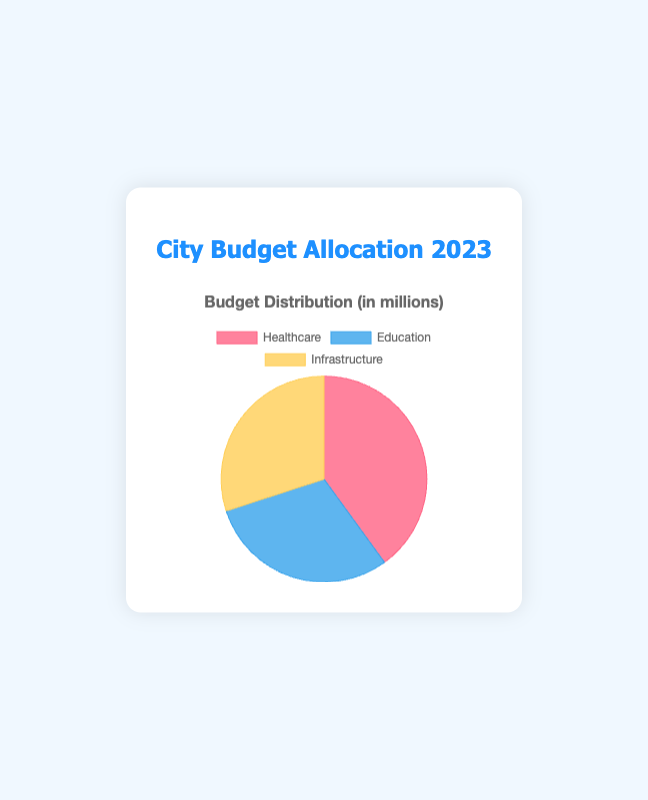What percentage of the budget is allocated to Healthcare? To find the percentage of the budget allocated to Healthcare, divide the Healthcare budget by the total budget and then multiply by 100. The total budget is 4,000,000 (Healthcare) + 3,000,000 (Education) + 3,000,000 (Infrastructure) = 10,000,000. Thus, (4,000,000 / 10,000,000) * 100 = 40%.
Answer: 40% How does the allocation for Education compare to that for Infrastructure? Both Education and Infrastructure have the same budget allocation of 3,000,000. Therefore, when comparing, they are equal in terms of budget allocation.
Answer: Equal Which category received the largest amount of funding in 2023? By looking at the data, Healthcare received 4,000,000, which is more than Education and Infrastructure, each of which received 3,000,000. Therefore, Healthcare is the largest.
Answer: Healthcare What is the difference between the Healthcare and Education budgets? To find the difference, subtract the Education budget from the Healthcare budget. Thus, 4,000,000 (Healthcare) - 3,000,000 (Education) = 1,000,000.
Answer: 1,000,000 Which segment of the pie chart will appear the largest, and why? The segment representing Healthcare will appear the largest because it has the highest budget allocation of 4,000,000, compared to 3,000,000 each for Education and Infrastructure.
Answer: Healthcare What is the combined budget for Education and Infrastructure? To find the combined budget, add the budgets for Education and Infrastructure. Thus, 3,000,000 (Education) + 3,000,000 (Infrastructure) = 6,000,000.
Answer: 6,000,000 If the total budget increases by 2,000,000 next year and is distributed equally among the three categories, what would be the new budget for each? First, add the additional 2,000,000 to the total budget, making it 12,000,000. Divide this equally among the three categories: 12,000,000 / 3 = 4,000,000 for each category.
Answer: 4,000,000 By how much did the Healthcare budget increase from 2022 to 2023? The Healthcare budget in 2023 is 4,000,000 and in 2022 it was 3,800,000. Therefore, the increase is 4,000,000 - 3,800,000 = 200,000.
Answer: 200,000 What color represents Education in the pie chart? The data specifies that the Education segment is represented in blue.
Answer: Blue 